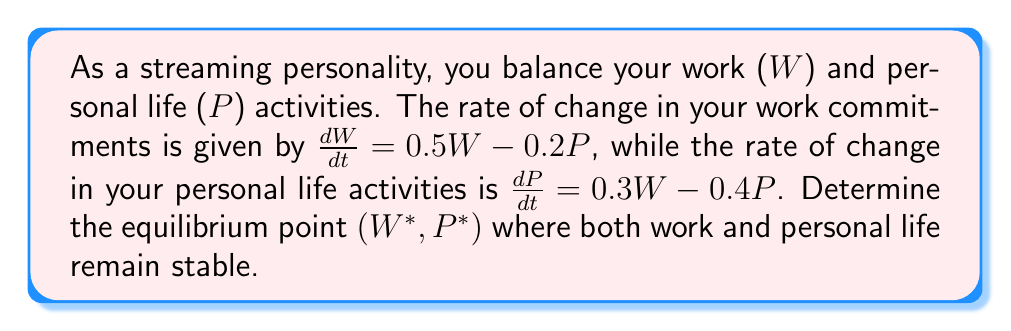Can you answer this question? To find the equilibrium point, we need to set both differential equations to zero and solve for W and P:

1) Set $\frac{dW}{dt} = 0$ and $\frac{dP}{dt} = 0$:
   $$0.5W - 0.2P = 0$$
   $$0.3W - 0.4P = 0$$

2) From the first equation:
   $$0.5W = 0.2P$$
   $$W = 0.4P$$

3) Substitute this into the second equation:
   $$0.3(0.4P) - 0.4P = 0$$
   $$0.12P - 0.4P = 0$$
   $$-0.28P = 0$$

4) Solve for P:
   $$P = 0$$

5) If $P = 0$, then from step 2, $W = 0.4(0) = 0$

Therefore, the equilibrium point is $(W^*, P^*) = (0, 0)$.

This means that the stable state is when both work and personal life activities are at zero, which in reality would represent a balanced state where neither is dominating the other.
Answer: $(W^*, P^*) = (0, 0)$ 